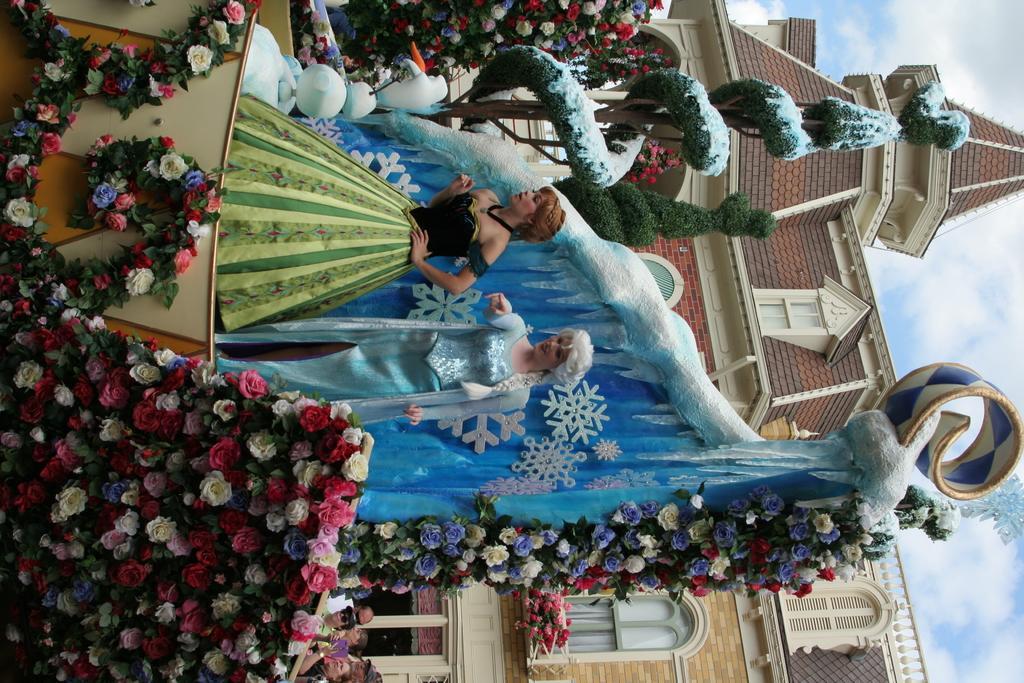Can you describe this image briefly? In this image there are two mannequin and they are decorated in the background there is a church. 